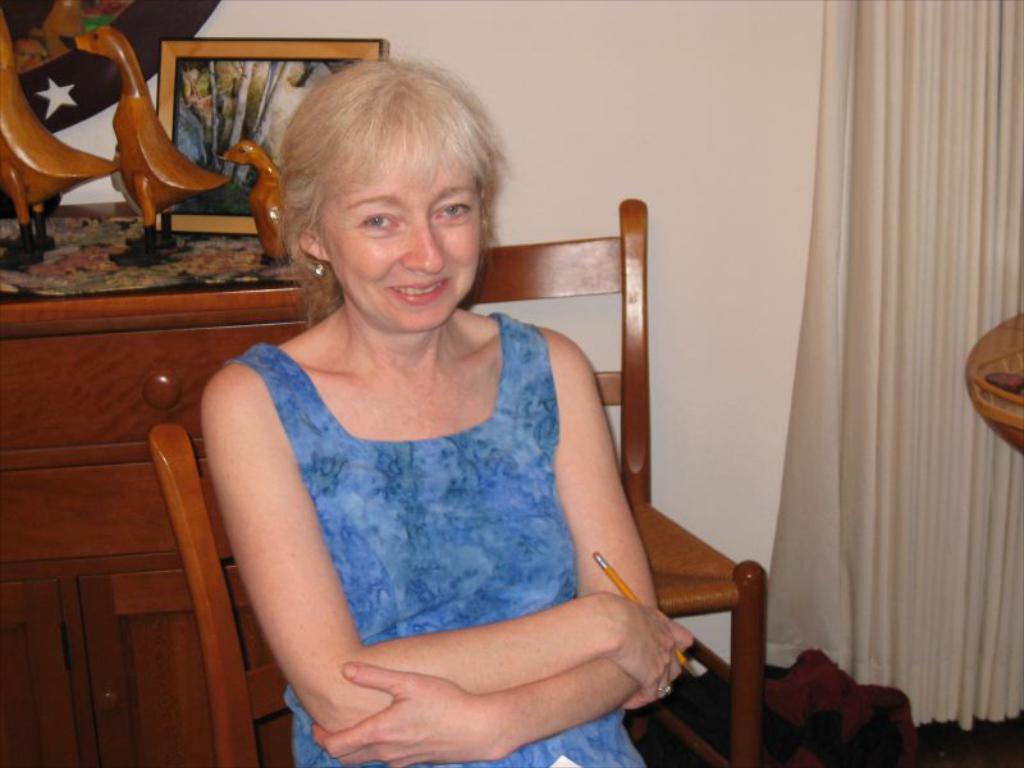How would you summarize this image in a sentence or two? This is the woman sitting on the chair and smiling. This is a curtain hanging. I can see a wardrobe with desk. These are the wooden toys,frame placed on the desk. This is the wall which is white in color. I can see another chair behind the women. 